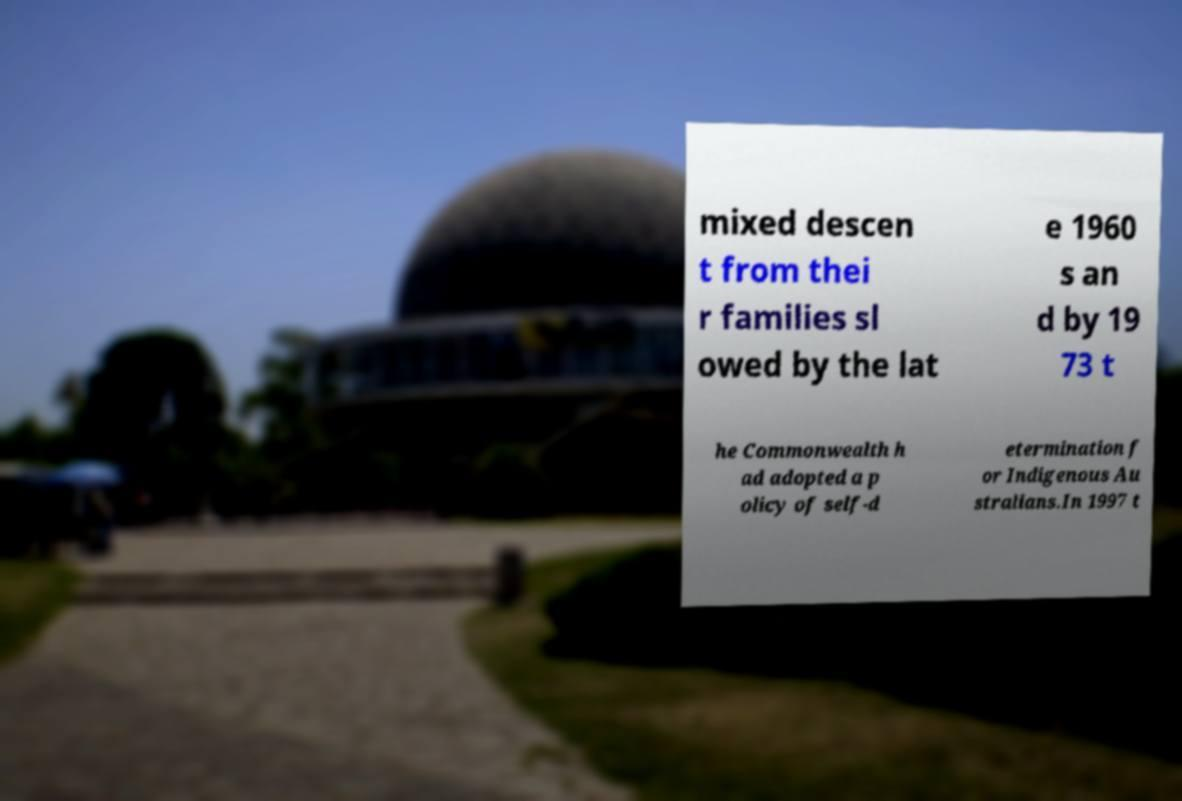What messages or text are displayed in this image? I need them in a readable, typed format. mixed descen t from thei r families sl owed by the lat e 1960 s an d by 19 73 t he Commonwealth h ad adopted a p olicy of self-d etermination f or Indigenous Au stralians.In 1997 t 